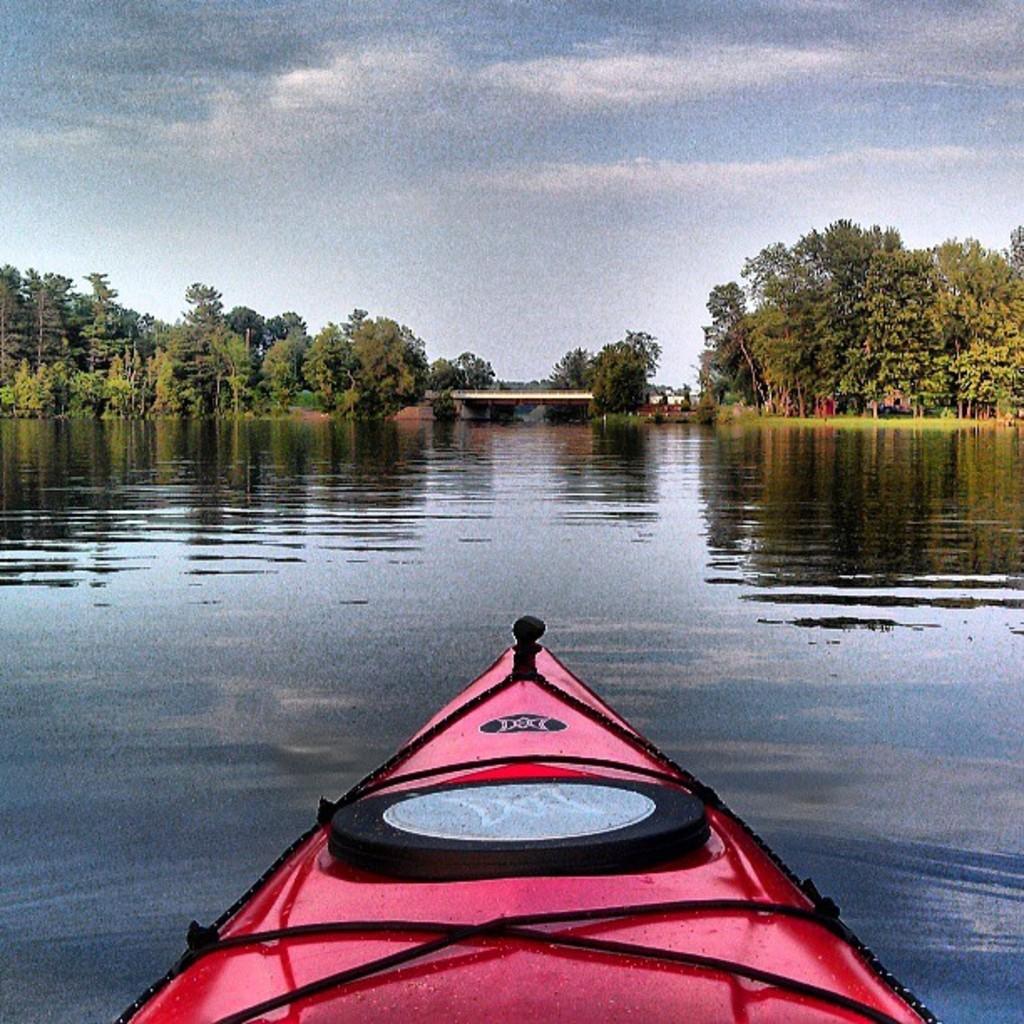Can you describe this image briefly? In this image we can see a boat on the water. In the background there are trees, bridge and sky. 